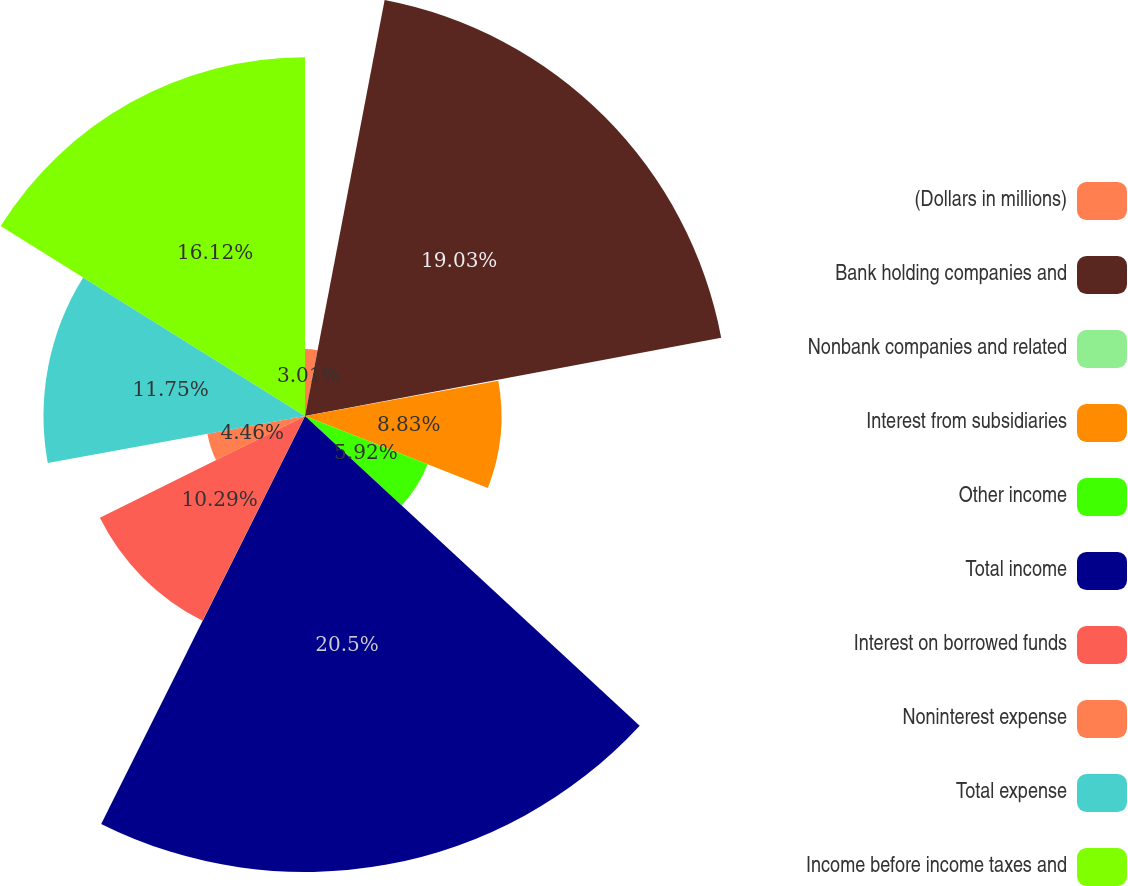<chart> <loc_0><loc_0><loc_500><loc_500><pie_chart><fcel>(Dollars in millions)<fcel>Bank holding companies and<fcel>Nonbank companies and related<fcel>Interest from subsidiaries<fcel>Other income<fcel>Total income<fcel>Interest on borrowed funds<fcel>Noninterest expense<fcel>Total expense<fcel>Income before income taxes and<nl><fcel>3.01%<fcel>19.03%<fcel>0.09%<fcel>8.83%<fcel>5.92%<fcel>20.49%<fcel>10.29%<fcel>4.46%<fcel>11.75%<fcel>16.12%<nl></chart> 